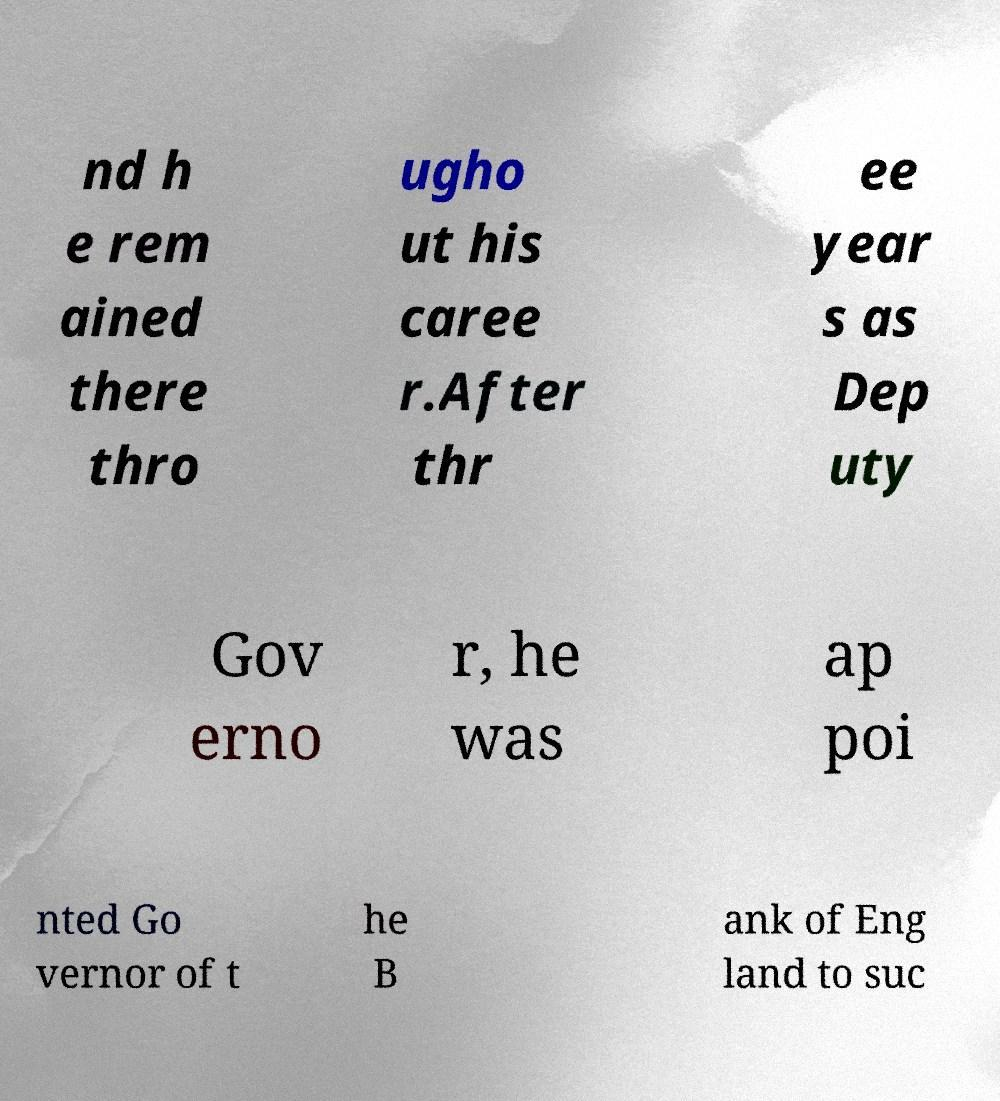What messages or text are displayed in this image? I need them in a readable, typed format. nd h e rem ained there thro ugho ut his caree r.After thr ee year s as Dep uty Gov erno r, he was ap poi nted Go vernor of t he B ank of Eng land to suc 